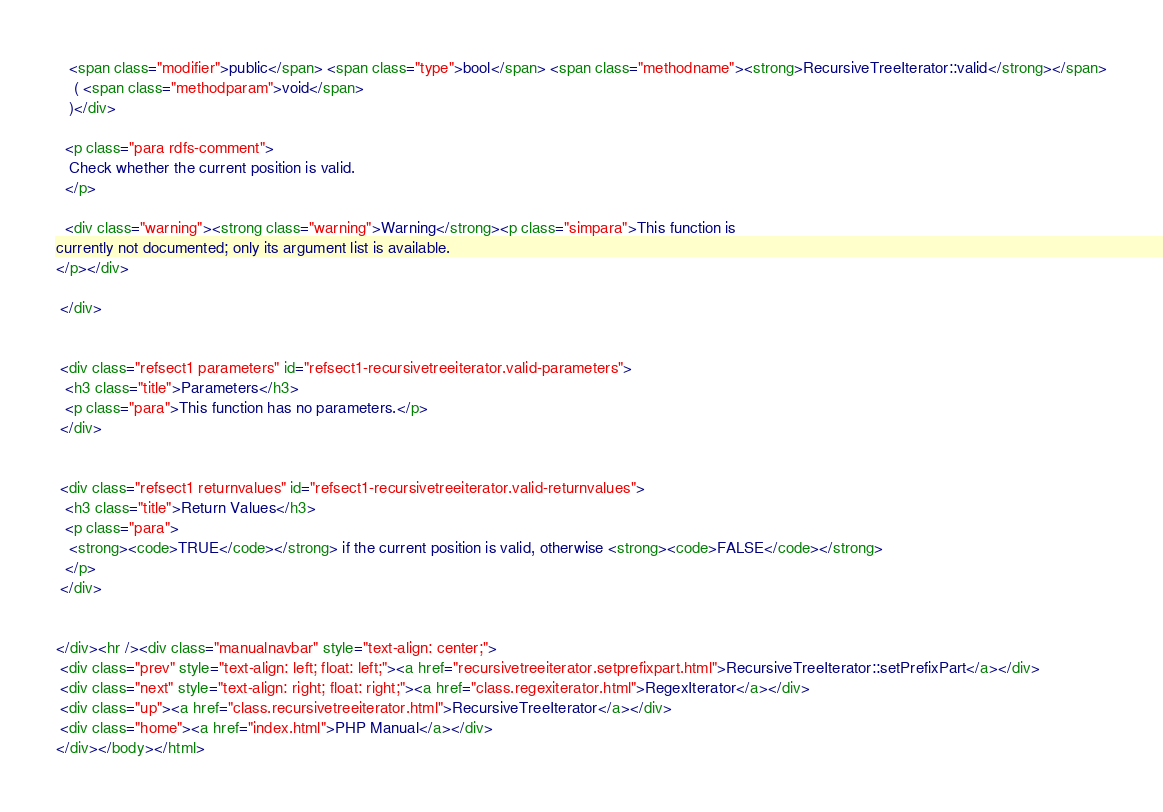<code> <loc_0><loc_0><loc_500><loc_500><_HTML_>   <span class="modifier">public</span> <span class="type">bool</span> <span class="methodname"><strong>RecursiveTreeIterator::valid</strong></span>
    ( <span class="methodparam">void</span>
   )</div>

  <p class="para rdfs-comment">
   Check whether the current position is valid.
  </p>

  <div class="warning"><strong class="warning">Warning</strong><p class="simpara">This function is
currently not documented; only its argument list is available.
</p></div>

 </div>


 <div class="refsect1 parameters" id="refsect1-recursivetreeiterator.valid-parameters">
  <h3 class="title">Parameters</h3>
  <p class="para">This function has no parameters.</p>
 </div>


 <div class="refsect1 returnvalues" id="refsect1-recursivetreeiterator.valid-returnvalues">
  <h3 class="title">Return Values</h3>
  <p class="para">
   <strong><code>TRUE</code></strong> if the current position is valid, otherwise <strong><code>FALSE</code></strong>
  </p>
 </div>


</div><hr /><div class="manualnavbar" style="text-align: center;">
 <div class="prev" style="text-align: left; float: left;"><a href="recursivetreeiterator.setprefixpart.html">RecursiveTreeIterator::setPrefixPart</a></div>
 <div class="next" style="text-align: right; float: right;"><a href="class.regexiterator.html">RegexIterator</a></div>
 <div class="up"><a href="class.recursivetreeiterator.html">RecursiveTreeIterator</a></div>
 <div class="home"><a href="index.html">PHP Manual</a></div>
</div></body></html>
</code> 